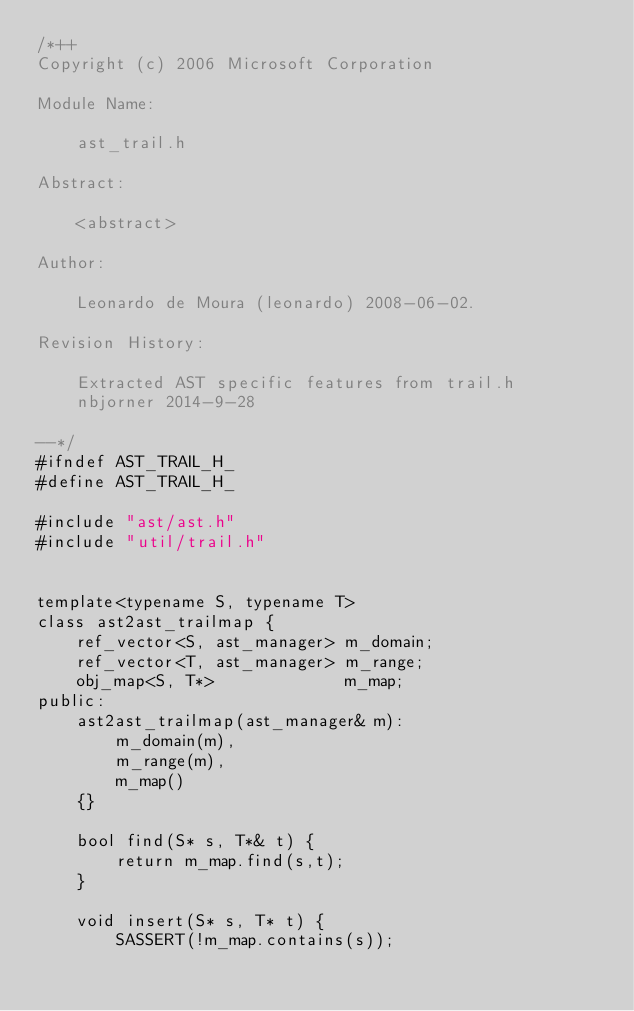Convert code to text. <code><loc_0><loc_0><loc_500><loc_500><_C_>/*++
Copyright (c) 2006 Microsoft Corporation

Module Name:

    ast_trail.h

Abstract:

    <abstract>

Author:

    Leonardo de Moura (leonardo) 2008-06-02.

Revision History:

    Extracted AST specific features from trail.h
    nbjorner 2014-9-28

--*/
#ifndef AST_TRAIL_H_
#define AST_TRAIL_H_

#include "ast/ast.h"
#include "util/trail.h"


template<typename S, typename T>
class ast2ast_trailmap {
    ref_vector<S, ast_manager> m_domain;
    ref_vector<T, ast_manager> m_range;
    obj_map<S, T*>             m_map;
public:
    ast2ast_trailmap(ast_manager& m):
        m_domain(m),
        m_range(m), 
        m_map()
    {}

    bool find(S* s, T*& t) {
        return m_map.find(s,t);
    }
    
    void insert(S* s, T* t) {
        SASSERT(!m_map.contains(s));</code> 